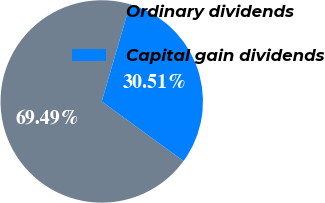Convert chart to OTSL. <chart><loc_0><loc_0><loc_500><loc_500><pie_chart><fcel>Ordinary dividends<fcel>Capital gain dividends<nl><fcel>69.49%<fcel>30.51%<nl></chart> 